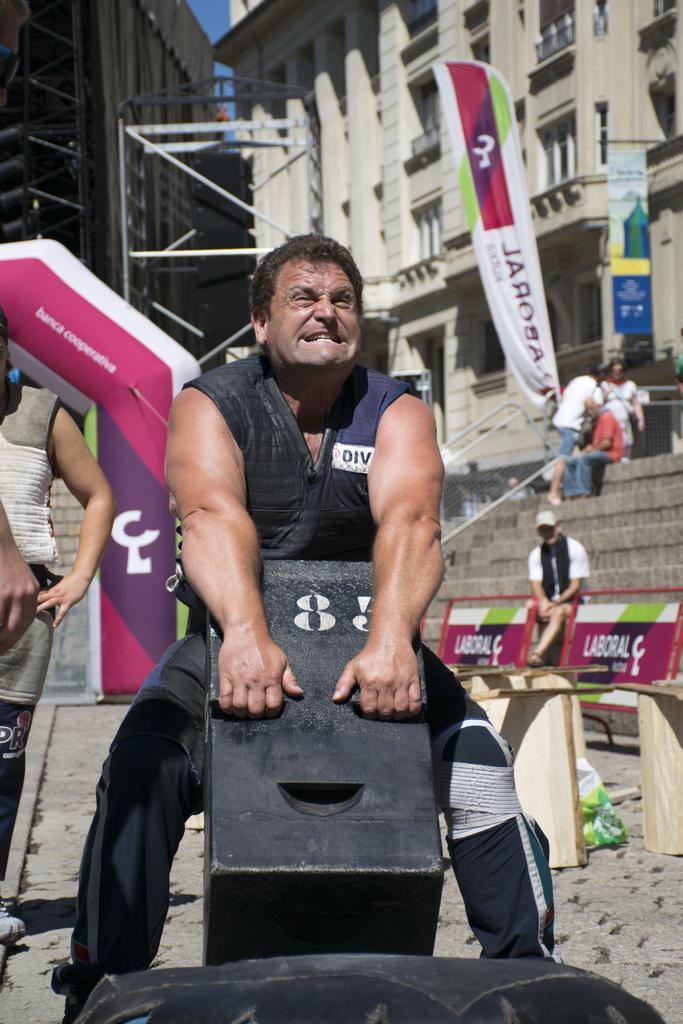How would you summarize this image in a sentence or two? In the center of the image, we can see a person holding an object and in the background, there are people, banners, a tube and some boards and stands and there are buildings and rods and we can see stairs. 